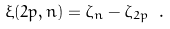<formula> <loc_0><loc_0><loc_500><loc_500>\xi ( 2 p , n ) = \zeta _ { n } - \zeta _ { 2 p } \ .</formula> 